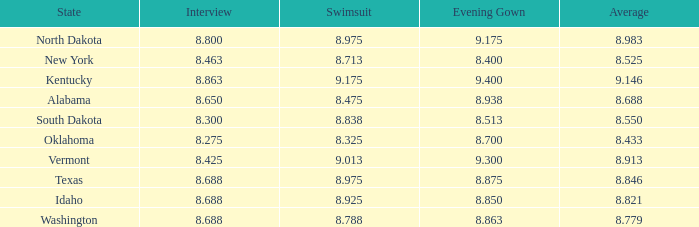Who had the lowest interview score from South Dakota with an evening gown less than 8.513? None. 